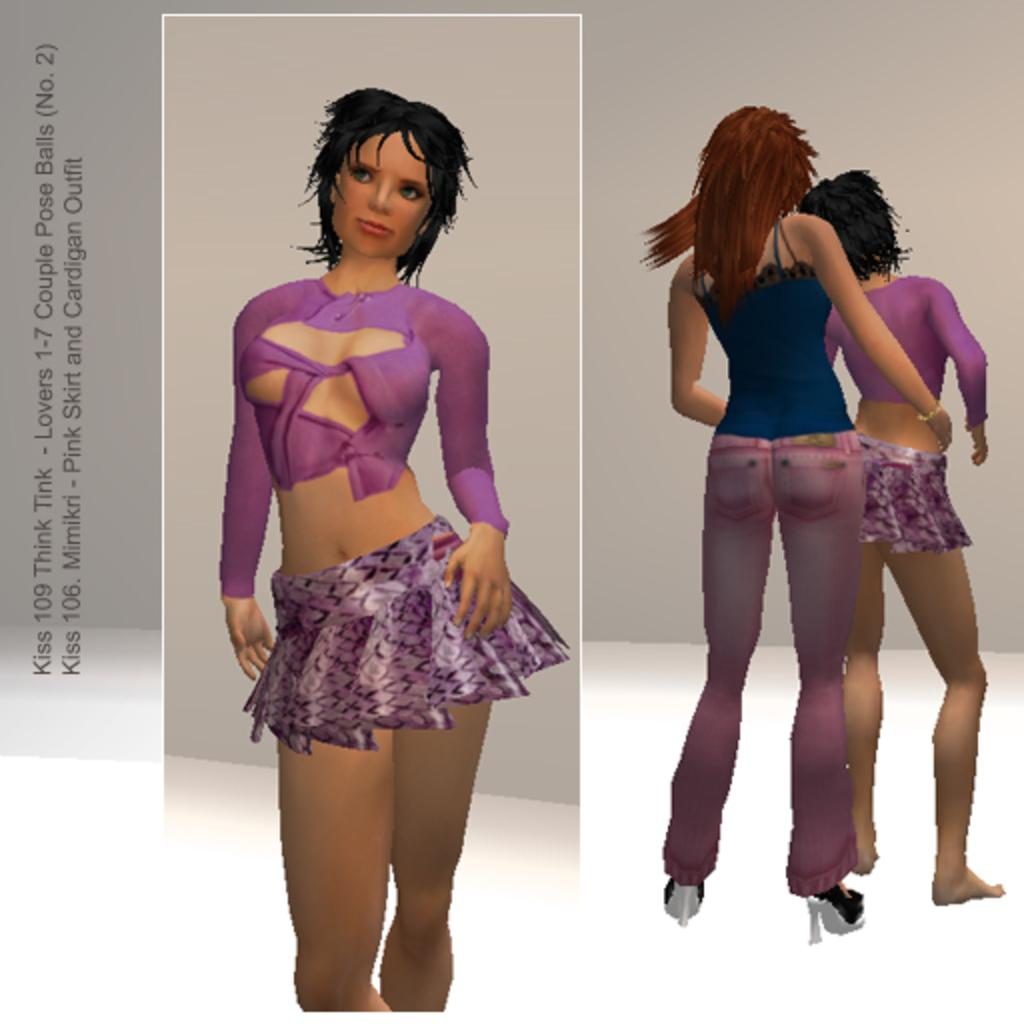What type of characters are present in the image? There are animated persons in the image. Where can text be found in the image? The text is located on the left side of the image. What type of feast is being prepared by the animated persons in the image? There is no feast or any indication of food preparation in the image; it only features animated persons and text. Can you see a bat flying in the image? There is no bat present in the image. 